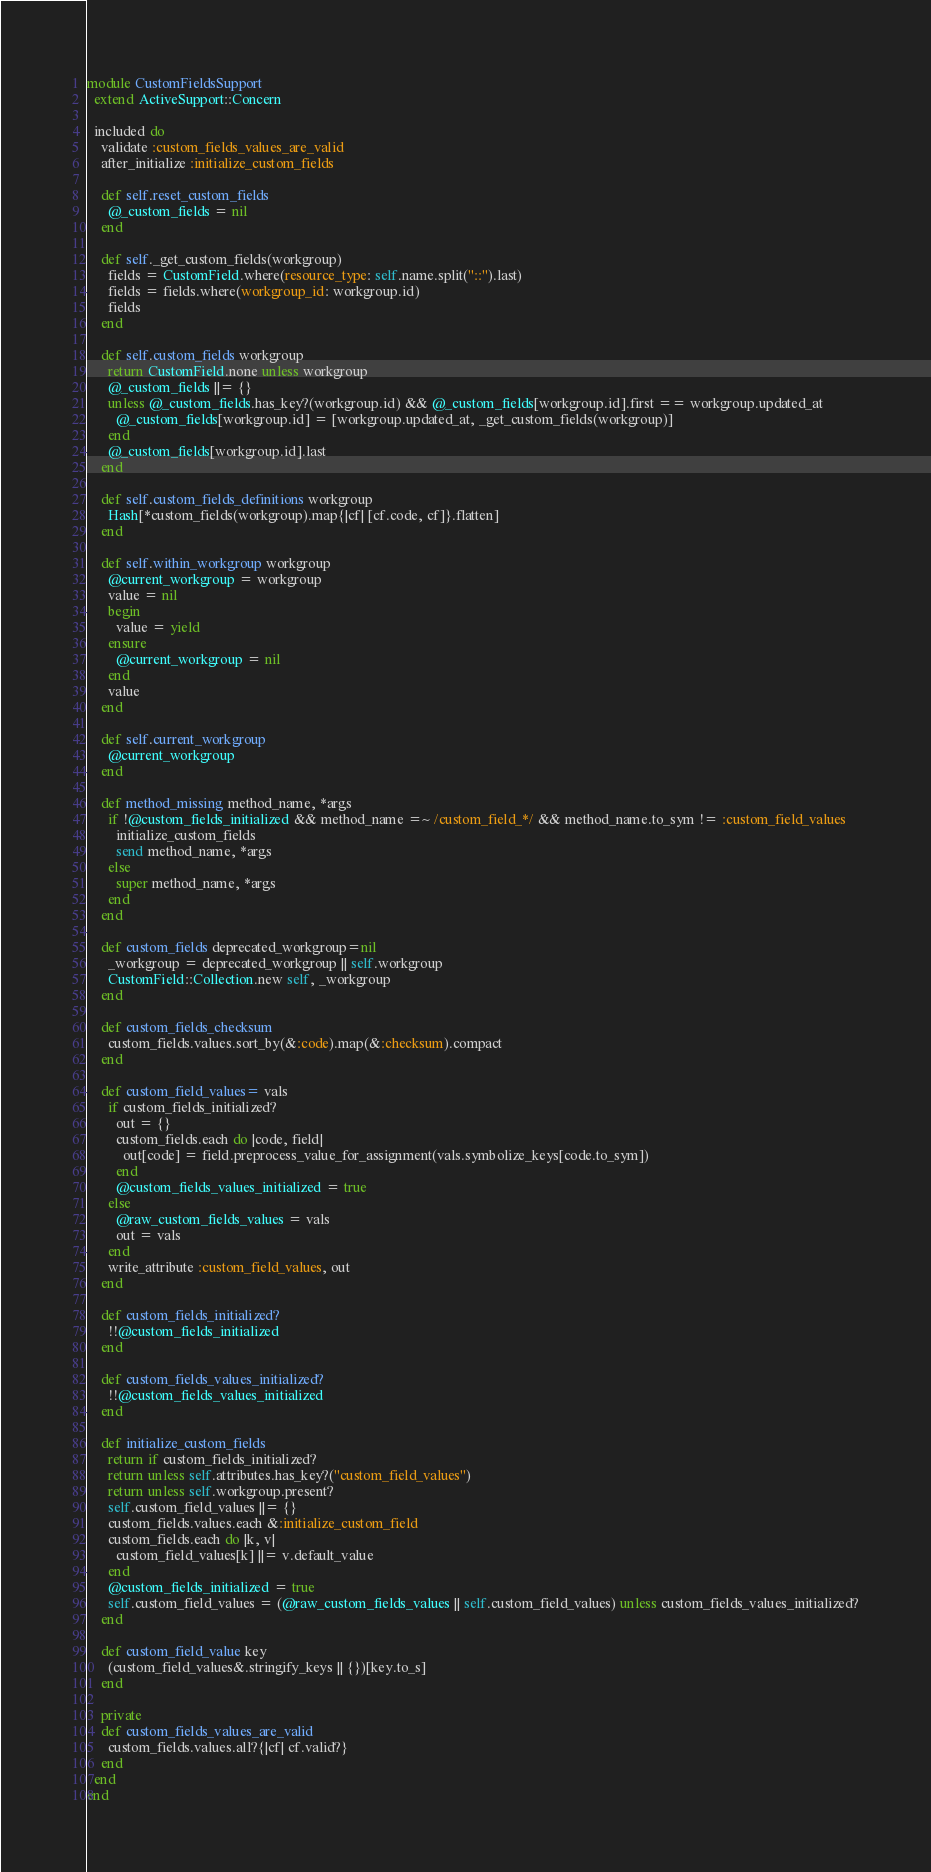<code> <loc_0><loc_0><loc_500><loc_500><_Ruby_>module CustomFieldsSupport
  extend ActiveSupport::Concern

  included do
    validate :custom_fields_values_are_valid
    after_initialize :initialize_custom_fields

    def self.reset_custom_fields
      @_custom_fields = nil
    end

    def self._get_custom_fields(workgroup)
      fields = CustomField.where(resource_type: self.name.split("::").last)
      fields = fields.where(workgroup_id: workgroup.id)
      fields
    end

    def self.custom_fields workgroup
      return CustomField.none unless workgroup
      @_custom_fields ||= {}
      unless @_custom_fields.has_key?(workgroup.id) && @_custom_fields[workgroup.id].first == workgroup.updated_at
        @_custom_fields[workgroup.id] = [workgroup.updated_at, _get_custom_fields(workgroup)]
      end
      @_custom_fields[workgroup.id].last
    end

    def self.custom_fields_definitions workgroup
      Hash[*custom_fields(workgroup).map{|cf| [cf.code, cf]}.flatten]
    end

    def self.within_workgroup workgroup
      @current_workgroup = workgroup
      value = nil
      begin
        value = yield
      ensure
        @current_workgroup = nil
      end
      value
    end

    def self.current_workgroup
      @current_workgroup
    end

    def method_missing method_name, *args
      if !@custom_fields_initialized && method_name =~ /custom_field_*/ && method_name.to_sym != :custom_field_values
        initialize_custom_fields
        send method_name, *args
      else
        super method_name, *args
      end
    end

    def custom_fields deprecated_workgroup=nil
      _workgroup = deprecated_workgroup || self.workgroup
      CustomField::Collection.new self, _workgroup
    end

    def custom_fields_checksum
      custom_fields.values.sort_by(&:code).map(&:checksum).compact
    end

    def custom_field_values= vals
      if custom_fields_initialized?
        out = {}
        custom_fields.each do |code, field|
          out[code] = field.preprocess_value_for_assignment(vals.symbolize_keys[code.to_sym])
        end
        @custom_fields_values_initialized = true
      else
        @raw_custom_fields_values = vals
        out = vals
      end
      write_attribute :custom_field_values, out
    end

    def custom_fields_initialized?
      !!@custom_fields_initialized
    end

    def custom_fields_values_initialized?
      !!@custom_fields_values_initialized
    end

    def initialize_custom_fields
      return if custom_fields_initialized?
      return unless self.attributes.has_key?("custom_field_values")
      return unless self.workgroup.present?
      self.custom_field_values ||= {}
      custom_fields.values.each &:initialize_custom_field
      custom_fields.each do |k, v|
        custom_field_values[k] ||= v.default_value
      end
      @custom_fields_initialized = true
      self.custom_field_values = (@raw_custom_fields_values || self.custom_field_values) unless custom_fields_values_initialized?
    end

    def custom_field_value key
      (custom_field_values&.stringify_keys || {})[key.to_s]
    end

    private
    def custom_fields_values_are_valid
      custom_fields.values.all?{|cf| cf.valid?}
    end
  end
end
</code> 